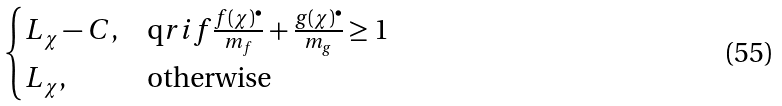Convert formula to latex. <formula><loc_0><loc_0><loc_500><loc_500>\begin{cases} L _ { \chi } - C , & \text  qr{if} \frac { f ( \chi ) ^ { \bullet } } { m _ { f } } + \frac { g ( \chi ) ^ { \bullet } } { m _ { g } } \geq 1 \\ L _ { \chi } , & \text {otherwise} \end{cases}</formula> 